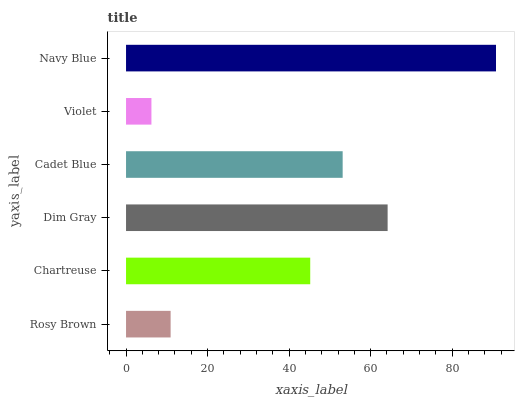Is Violet the minimum?
Answer yes or no. Yes. Is Navy Blue the maximum?
Answer yes or no. Yes. Is Chartreuse the minimum?
Answer yes or no. No. Is Chartreuse the maximum?
Answer yes or no. No. Is Chartreuse greater than Rosy Brown?
Answer yes or no. Yes. Is Rosy Brown less than Chartreuse?
Answer yes or no. Yes. Is Rosy Brown greater than Chartreuse?
Answer yes or no. No. Is Chartreuse less than Rosy Brown?
Answer yes or no. No. Is Cadet Blue the high median?
Answer yes or no. Yes. Is Chartreuse the low median?
Answer yes or no. Yes. Is Dim Gray the high median?
Answer yes or no. No. Is Cadet Blue the low median?
Answer yes or no. No. 